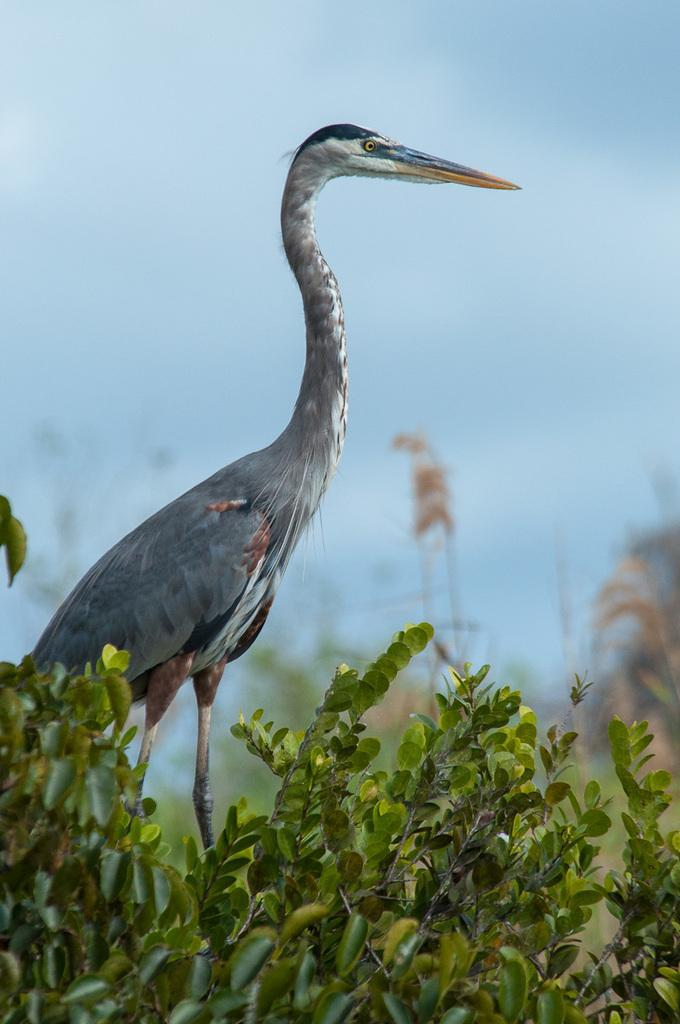What is the main subject of the image? The main subject of the image is a crane. What color is the crane in the image? The crane is grey in color. What type of vegetation is at the bottom of the image? There are trees at the bottom of the image. What is visible at the top of the image? The sky is visible at the top of the image. Where is the camera placed in the image? There is no camera present in the image. What type of underwear is the crane wearing in the image? Cranes are not capable of wearing underwear, and there is no underwear present in the image. 